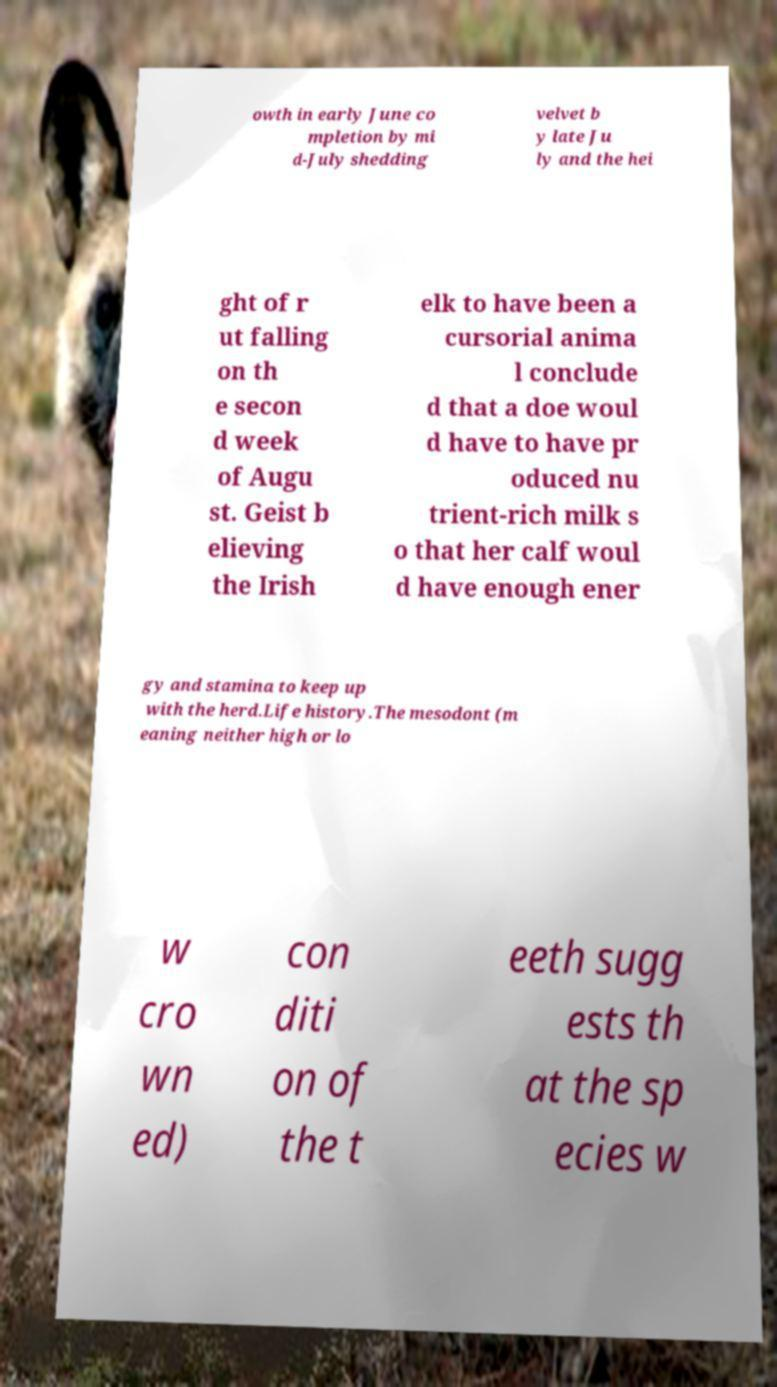Can you accurately transcribe the text from the provided image for me? owth in early June co mpletion by mi d-July shedding velvet b y late Ju ly and the hei ght of r ut falling on th e secon d week of Augu st. Geist b elieving the Irish elk to have been a cursorial anima l conclude d that a doe woul d have to have pr oduced nu trient-rich milk s o that her calf woul d have enough ener gy and stamina to keep up with the herd.Life history.The mesodont (m eaning neither high or lo w cro wn ed) con diti on of the t eeth sugg ests th at the sp ecies w 